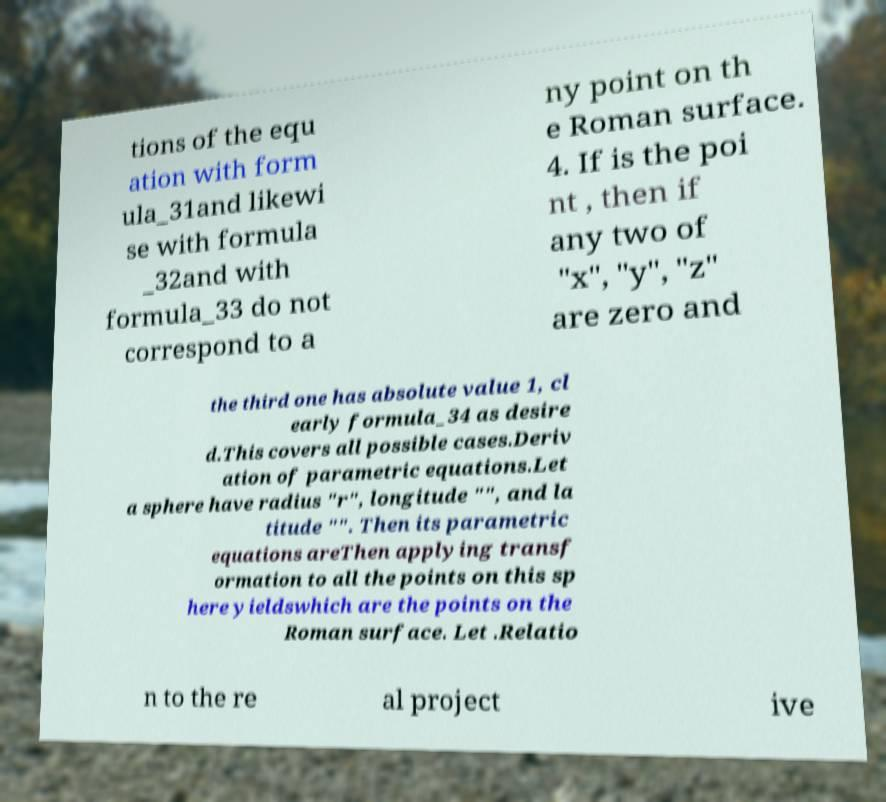Could you assist in decoding the text presented in this image and type it out clearly? tions of the equ ation with form ula_31and likewi se with formula _32and with formula_33 do not correspond to a ny point on th e Roman surface. 4. If is the poi nt , then if any two of "x", "y", "z" are zero and the third one has absolute value 1, cl early formula_34 as desire d.This covers all possible cases.Deriv ation of parametric equations.Let a sphere have radius "r", longitude "", and la titude "". Then its parametric equations areThen applying transf ormation to all the points on this sp here yieldswhich are the points on the Roman surface. Let .Relatio n to the re al project ive 